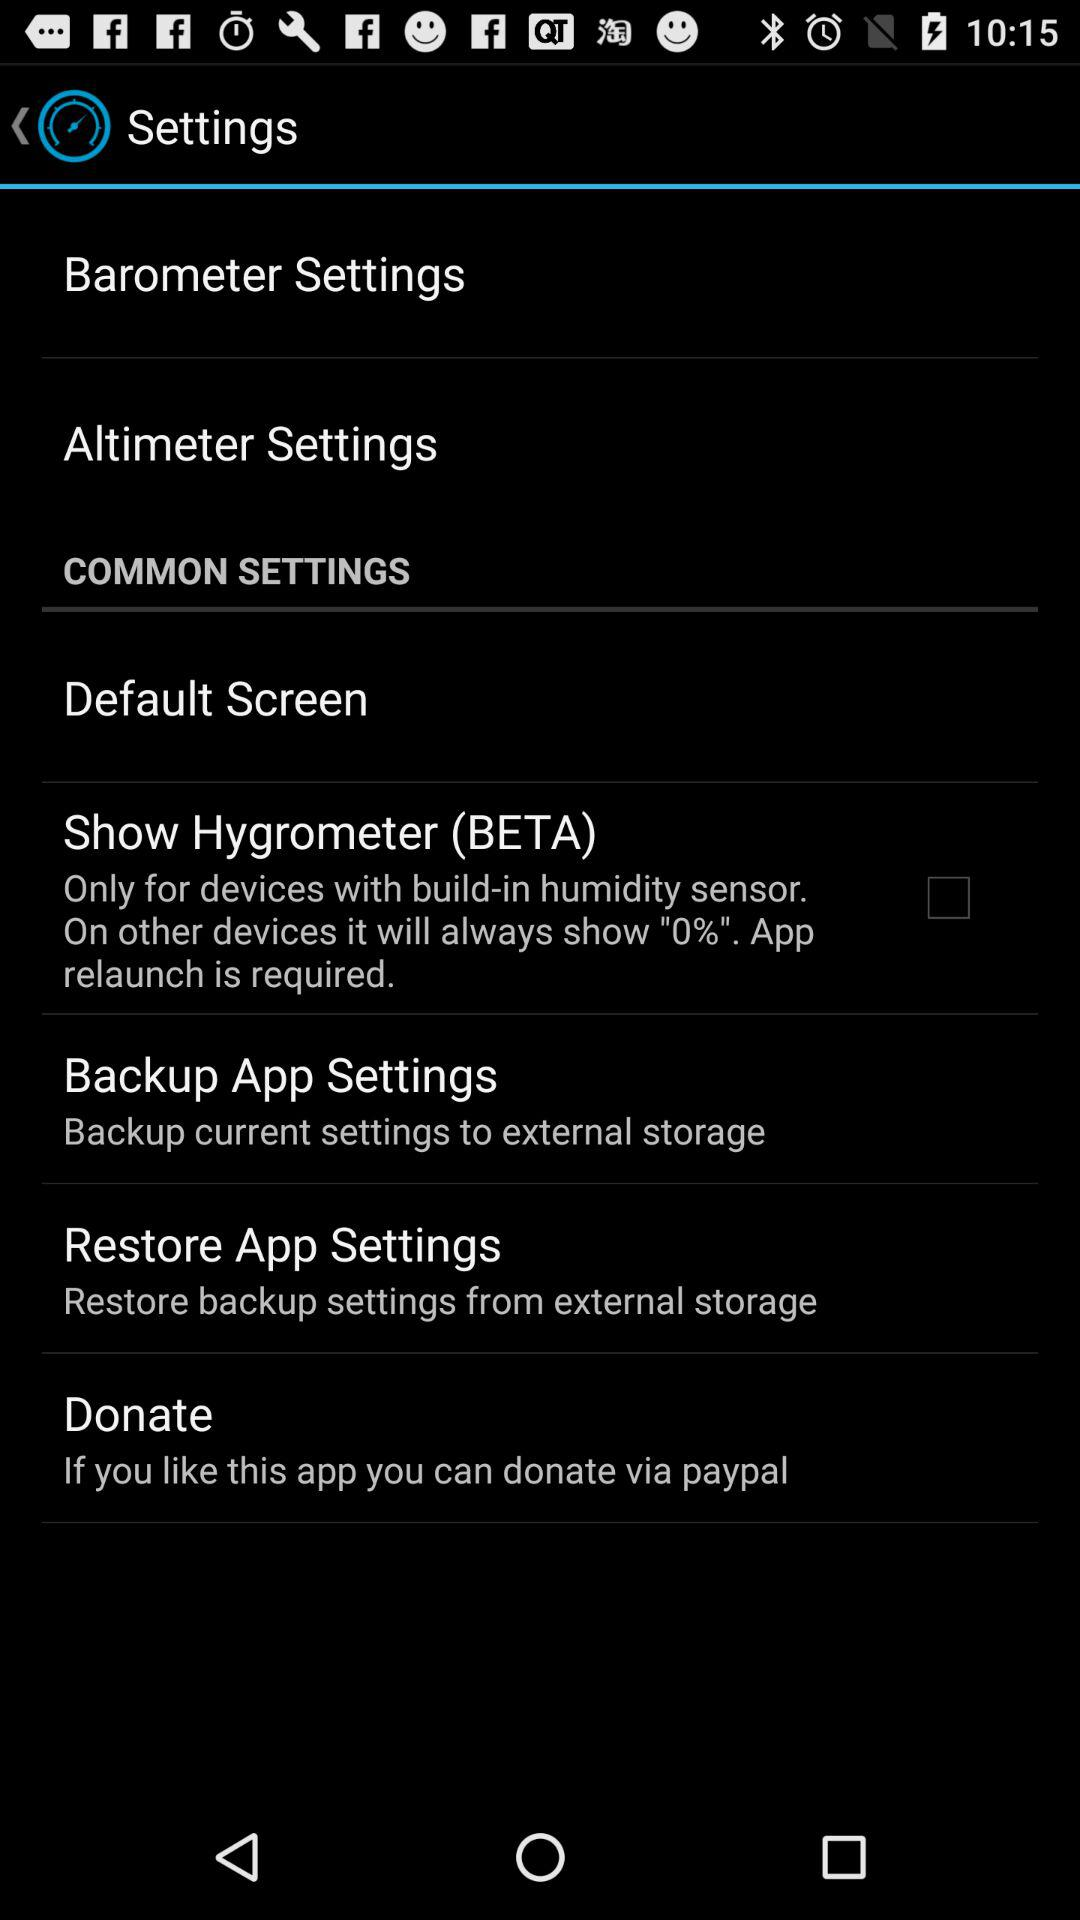What is the status of the "Show Hygrometer (BETA)" setting? The status is "off". 